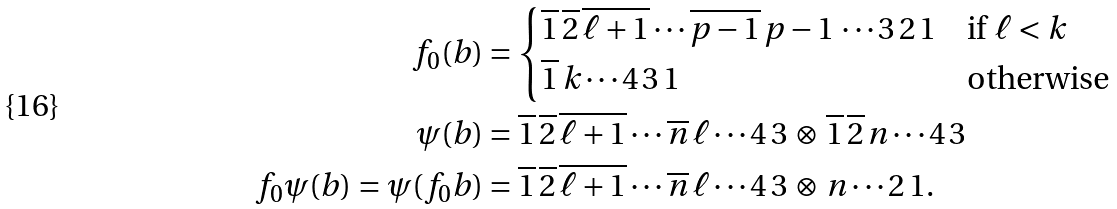<formula> <loc_0><loc_0><loc_500><loc_500>f _ { 0 } ( b ) & = \begin{cases} \overline { 1 } \, \overline { 2 } \, \overline { \ell + 1 } \cdots \overline { p - 1 } \, p - 1 \, \cdots 3 \, 2 \, 1 & \text {if $\ell<k$} \\ \overline { 1 } \, k \cdots 4 \, 3 \, 1 & \text {otherwise} \end{cases} \\ \psi ( b ) & = \overline { 1 } \, \overline { 2 } \, \overline { \ell + 1 } \cdots \overline { n } \, \ell \cdots 4 \, 3 \, \otimes \, \overline { 1 } \, \overline { 2 } \, n \cdots 4 \, 3 \\ f _ { 0 } \psi ( b ) = \psi ( f _ { 0 } b ) & = \overline { 1 } \, \overline { 2 } \, \overline { \ell + 1 } \cdots \overline { n } \, \ell \cdots 4 \, 3 \, \otimes \, n \cdots 2 \, 1 .</formula> 